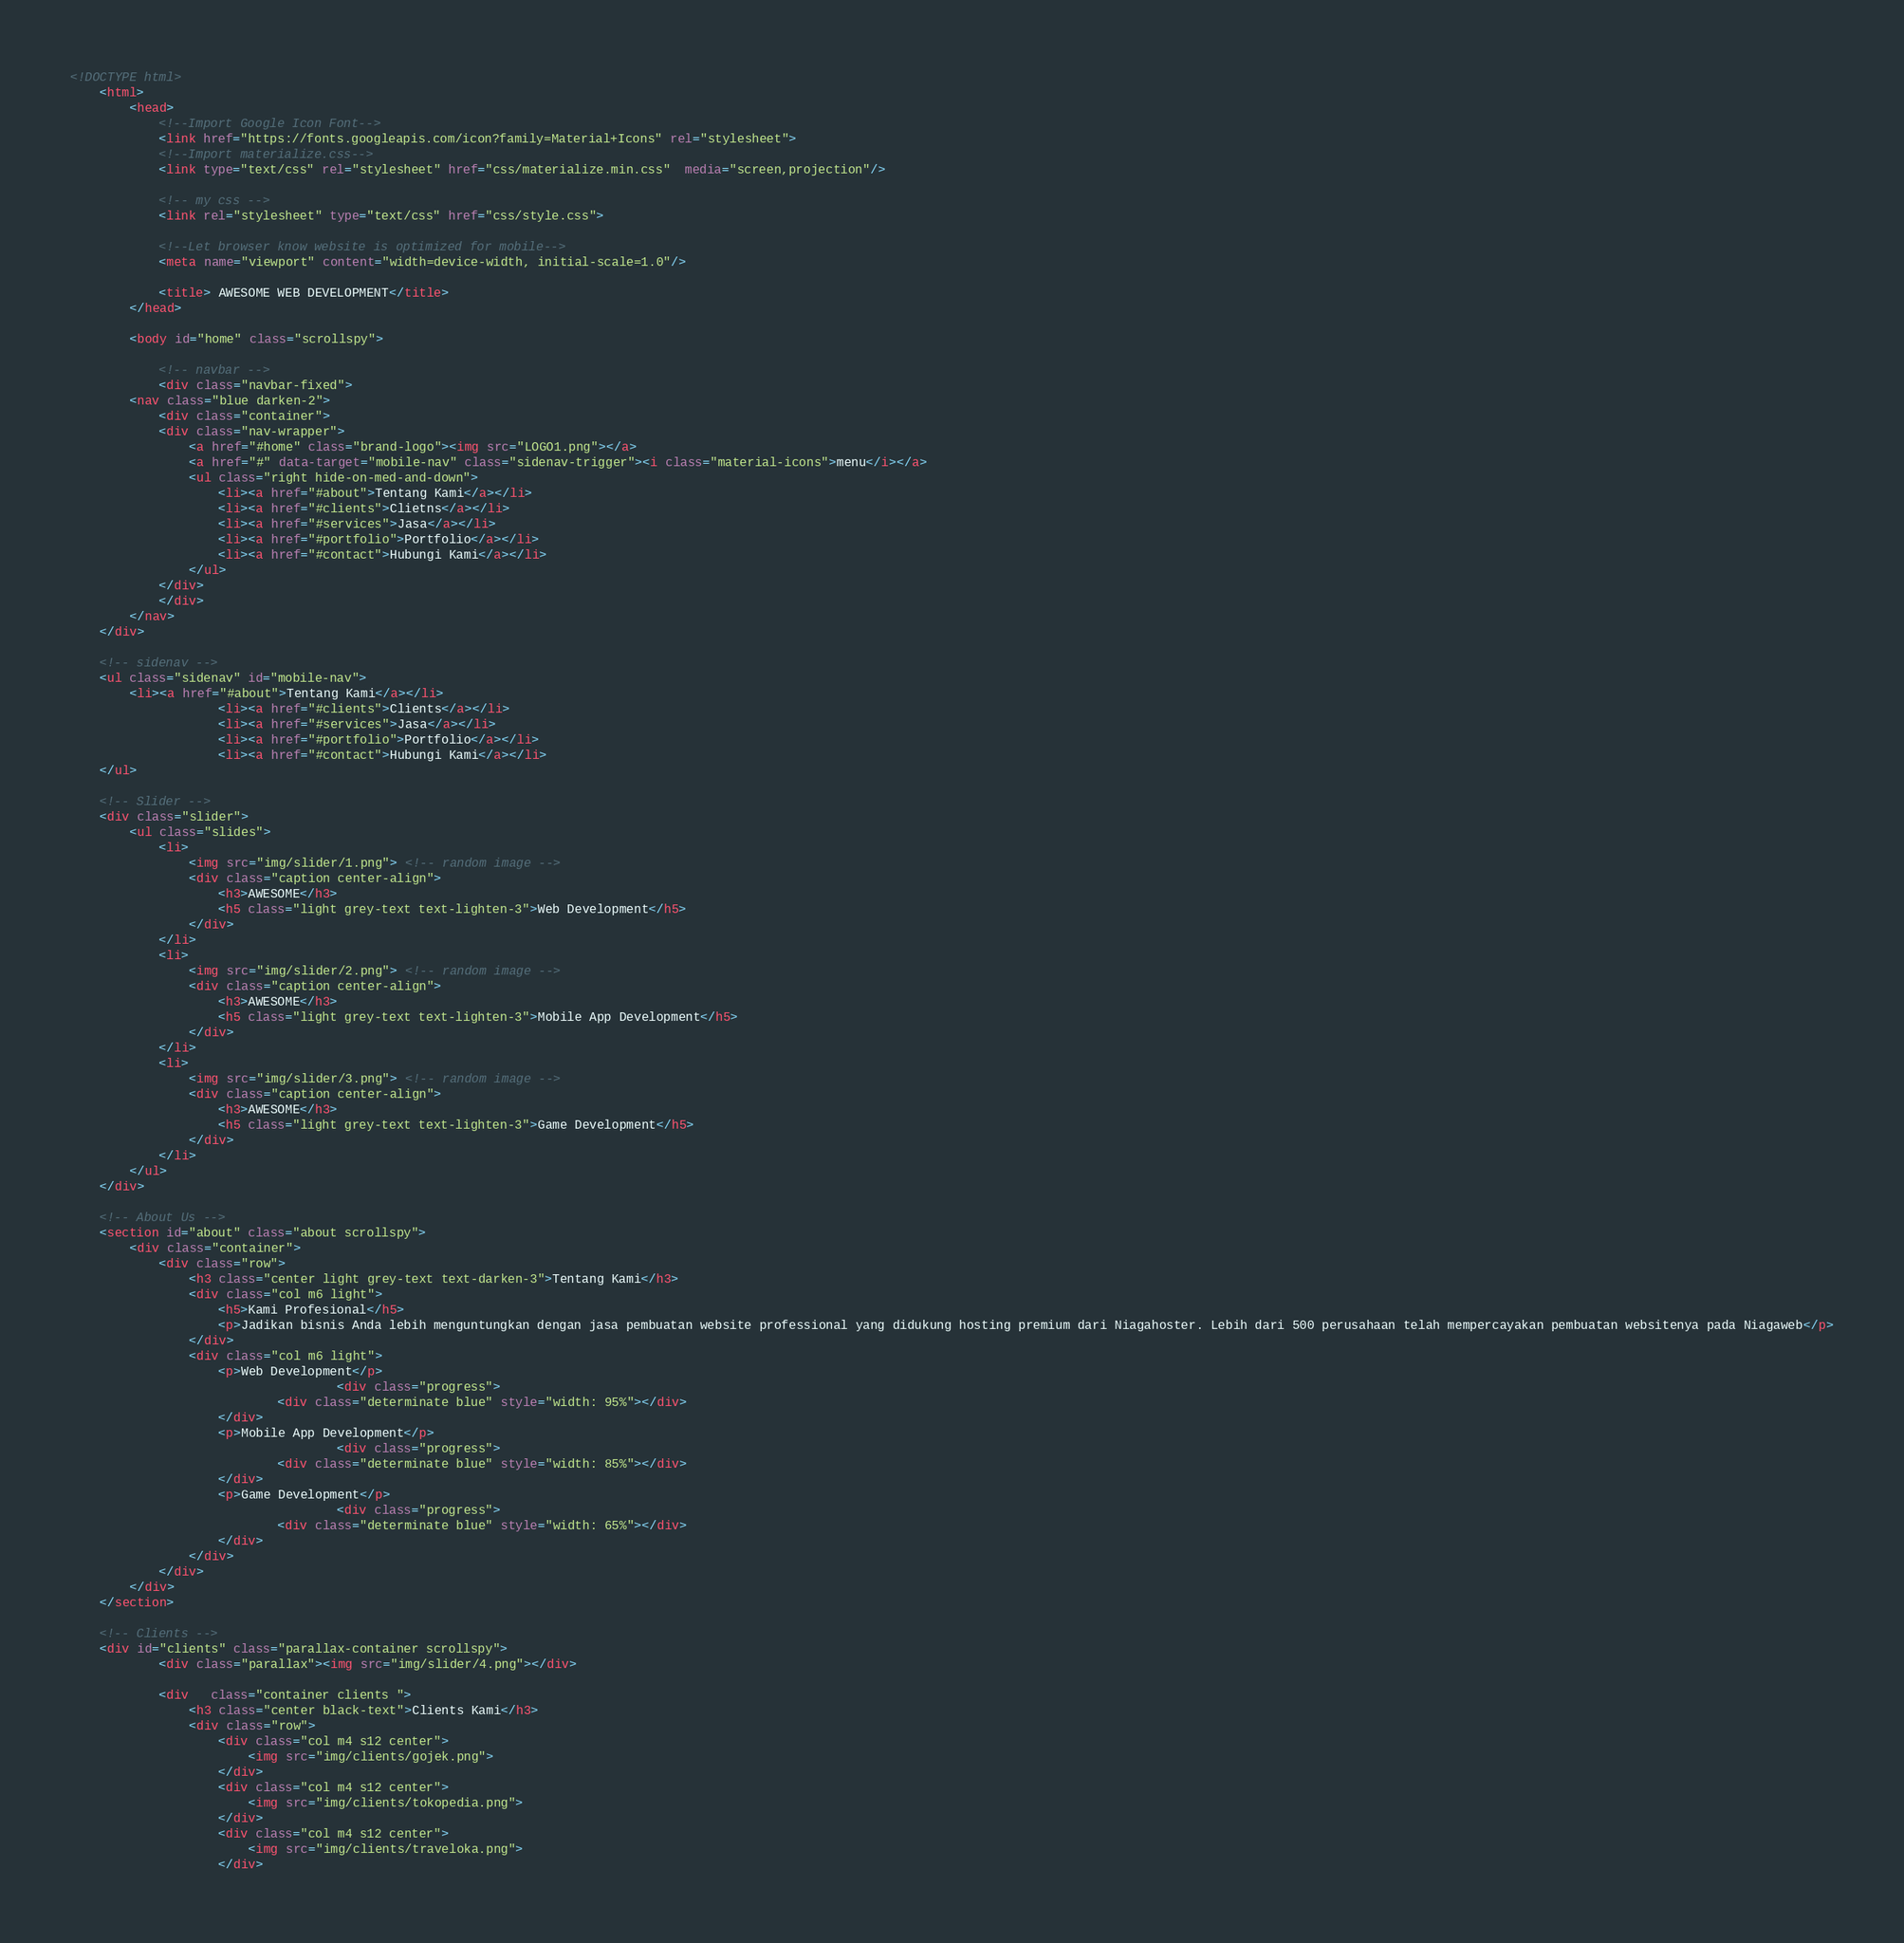<code> <loc_0><loc_0><loc_500><loc_500><_HTML_><!DOCTYPE html>
	<html>
		<head>
			<!--Import Google Icon Font-->
			<link href="https://fonts.googleapis.com/icon?family=Material+Icons" rel="stylesheet">
			<!--Import materialize.css-->
			<link type="text/css" rel="stylesheet" href="css/materialize.min.css"  media="screen,projection"/>

			<!-- my css -->
			<link rel="stylesheet" type="text/css" href="css/style.css">

			<!--Let browser know website is optimized for mobile-->
			<meta name="viewport" content="width=device-width, initial-scale=1.0"/>

			<title> AWESOME WEB DEVELOPMENT</title>
		</head>

		<body id="home" class="scrollspy">

			<!-- navbar -->
			<div class="navbar-fixed">
		<nav class="blue darken-2">
			<div class="container">
			<div class="nav-wrapper">
				<a href="#home" class="brand-logo"><img src="LOGO1.png"></a>
				<a href="#" data-target="mobile-nav" class="sidenav-trigger"><i class="material-icons">menu</i></a>
				<ul class="right hide-on-med-and-down">
					<li><a href="#about">Tentang Kami</a></li>
					<li><a href="#clients">Clietns</a></li>
					<li><a href="#services">Jasa</a></li>
					<li><a href="#portfolio">Portfolio</a></li>
					<li><a href="#contact">Hubungi Kami</a></li>
				</ul>
			</div>
			</div>
		</nav>
	</div>

	<!-- sidenav -->
	<ul class="sidenav" id="mobile-nav">
		<li><a href="#about">Tentang Kami</a></li>
					<li><a href="#clients">Clients</a></li>
					<li><a href="#services">Jasa</a></li>
					<li><a href="#portfolio">Portfolio</a></li>
					<li><a href="#contact">Hubungi Kami</a></li>
	</ul>

	<!-- Slider -->
	<div class="slider">
		<ul class="slides">
			<li>
				<img src="img/slider/1.png"> <!-- random image -->
				<div class="caption center-align">
					<h3>AWESOME</h3>
					<h5 class="light grey-text text-lighten-3">Web Development</h5>
				</div>
			</li>
			<li>
				<img src="img/slider/2.png"> <!-- random image -->
				<div class="caption center-align">
					<h3>AWESOME</h3>
					<h5 class="light grey-text text-lighten-3">Mobile App Development</h5>
				</div>
			</li>
			<li>
				<img src="img/slider/3.png"> <!-- random image -->
				<div class="caption center-align">
					<h3>AWESOME</h3>
					<h5 class="light grey-text text-lighten-3">Game Development</h5>
				</div>
			</li>
		</ul>
	</div>

	<!-- About Us -->
	<section id="about" class="about scrollspy">
		<div class="container">
			<div class="row">
				<h3 class="center light grey-text text-darken-3">Tentang Kami</h3>
				<div class="col m6 light">
					<h5>Kami Profesional</h5>
					<p>Jadikan bisnis Anda lebih menguntungkan dengan jasa pembuatan website professional yang didukung hosting premium dari Niagahoster. Lebih dari 500 perusahaan telah mempercayakan pembuatan websitenya pada Niagaweb</p>
				</div>
				<div class="col m6 light">
					<p>Web Development</p>
									<div class="progress">
							<div class="determinate blue" style="width: 95%"></div>
					</div>
					<p>Mobile App Development</p>
									<div class="progress">
							<div class="determinate blue" style="width: 85%"></div>
					</div>
					<p>Game Development</p>
									<div class="progress">
							<div class="determinate blue" style="width: 65%"></div>
					</div>
				</div>
			</div>
		</div>
	</section>

	<!-- Clients -->
	<div id="clients" class="parallax-container scrollspy">
			<div class="parallax"><img src="img/slider/4.png"></div>

			<div   class="container clients ">
				<h3 class="center black-text">Clients Kami</h3>
				<div class="row">
					<div class="col m4 s12 center">
						<img src="img/clients/gojek.png">
					</div>
					<div class="col m4 s12 center">
						<img src="img/clients/tokopedia.png">
					</div>
					<div class="col m4 s12 center">
						<img src="img/clients/traveloka.png">
					</div></code> 